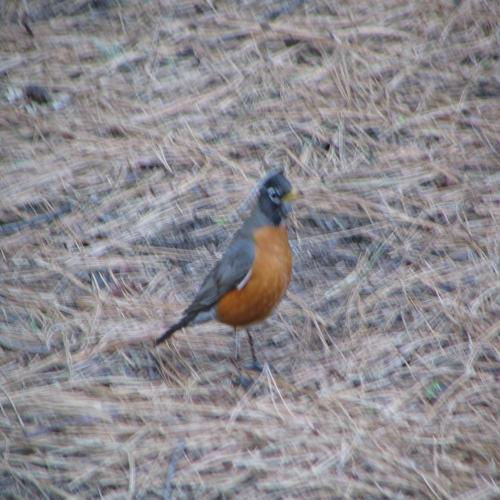Can you tell me what type of environment the bird is in? The image captures the bird in what looks to be a natural, grassy habitat, possibly a park or a garden. The ground is covered with dry grass, indicative of a place that is well-maintained or experiencing early autumn. 